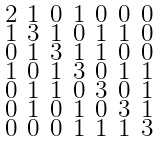Convert formula to latex. <formula><loc_0><loc_0><loc_500><loc_500>\begin{smallmatrix} 2 & 1 & 0 & 1 & 0 & 0 & 0 \\ 1 & 3 & 1 & 0 & 1 & 1 & 0 \\ 0 & 1 & 3 & 1 & 1 & 0 & 0 \\ 1 & 0 & 1 & 3 & 0 & 1 & 1 \\ 0 & 1 & 1 & 0 & 3 & 0 & 1 \\ 0 & 1 & 0 & 1 & 0 & 3 & 1 \\ 0 & 0 & 0 & 1 & 1 & 1 & 3 \end{smallmatrix}</formula> 